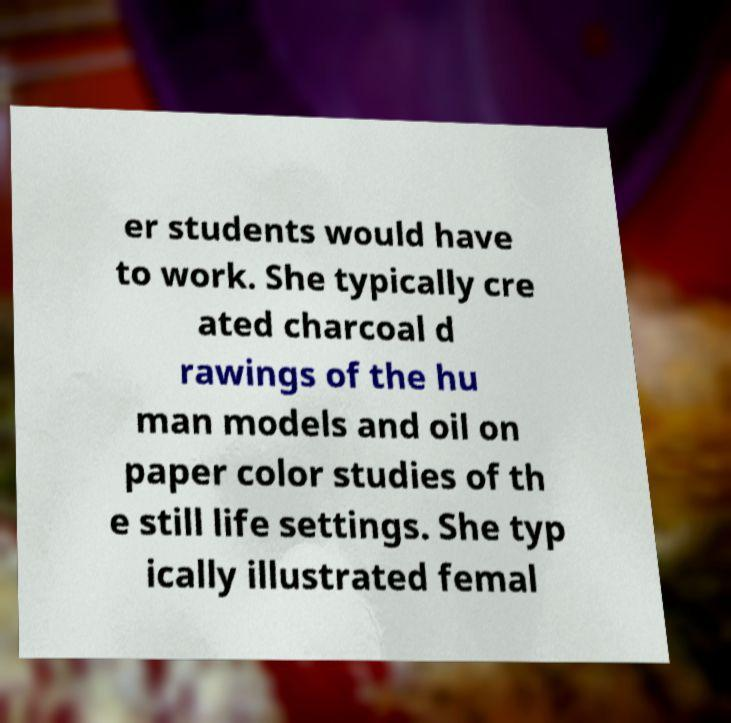Can you accurately transcribe the text from the provided image for me? er students would have to work. She typically cre ated charcoal d rawings of the hu man models and oil on paper color studies of th e still life settings. She typ ically illustrated femal 